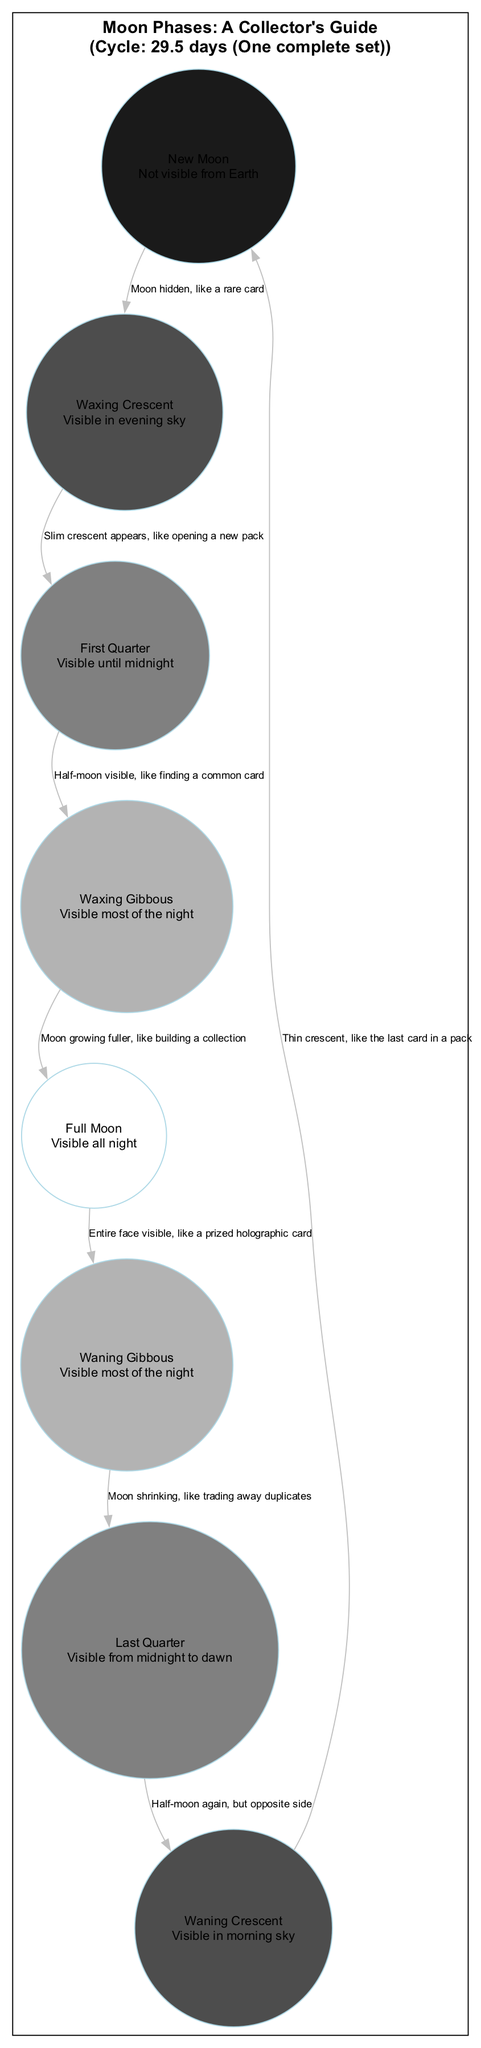What's the total number of moon phases depicted in the diagram? The diagram lists a total of eight distinct phases of the Moon: New Moon, Waxing Crescent, First Quarter, Waxing Gibbous, Full Moon, Waning Gibbous, Last Quarter, and Waning Crescent. Counting each one gives us the total of eight phases.
Answer: 8 Which moon phase is visible all night long? The Full Moon phase is specified in the diagram as being "Visible all night," indicating that this phase has full visibility from dusk until dawn.
Answer: Full Moon What phase comes after the Waxing Gibbous? Following the Waxing Gibbous phase, the diagram connects to the next phase in the sequence, which is the Full Moon. This is evident from the directed edges between the phases, showing how they flow and progress over the lunar cycle.
Answer: Full Moon During which phase is the Moon not visible from Earth? The New Moon phase is noted in the diagram as being "Not visible from Earth," indicating its complete absence in the night sky during this time.
Answer: New Moon What is the visibility period for the Last Quarter phase? The Last Quarter phase is indicated to be "Visible from midnight to dawn" in the diagram. This means it can be seen during the latter half of the night, specifically starting after midnight and continuing until sunrise.
Answer: Visible from midnight to dawn How long does one complete lunar cycle take? The diagram specifically states that one complete lunar cycle lasts 29.5 days. This duration represents the average time it takes for the Moon to transition through all the phases, from New Moon back to New Moon.
Answer: 29.5 days Which phase represents the Moon at its fullest? The Full Moon phase is described in the diagram as "Entire face visible," signifying that this phase is when the Moon appears completely illuminated from Earth's perspective.
Answer: Full Moon What description corresponds to the Waxing Crescent? The description attached to the Waxing Crescent phase is "Slim crescent appears, like opening a new pack," providing a vivid metaphor to illustrate the appearance of the Moon during this phase.
Answer: Slim crescent appears, like opening a new pack 